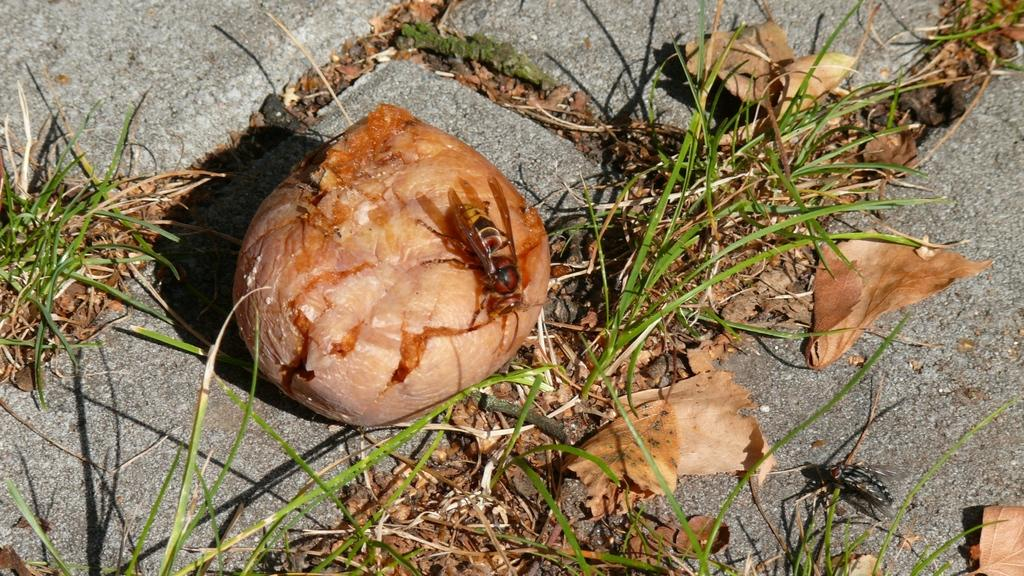What type of creature can be seen in the image? There is an insect in the image. What is the ground covered with in the image? There is grass on the ground in the image. What other natural elements can be seen in the image? There are dried leaves in the image. What type of scarf is the insect wearing in the image? There is no scarf present in the image, and insects do not wear clothing. 